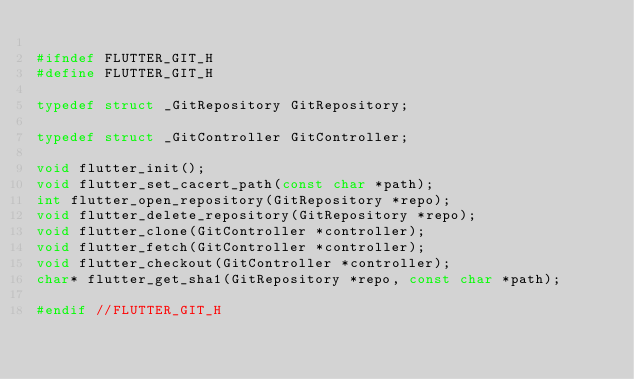<code> <loc_0><loc_0><loc_500><loc_500><_C_>
#ifndef FLUTTER_GIT_H
#define FLUTTER_GIT_H

typedef struct _GitRepository GitRepository;

typedef struct _GitController GitController;

void flutter_init();
void flutter_set_cacert_path(const char *path);
int flutter_open_repository(GitRepository *repo);
void flutter_delete_repository(GitRepository *repo);
void flutter_clone(GitController *controller);
void flutter_fetch(GitController *controller);
void flutter_checkout(GitController *controller);
char* flutter_get_sha1(GitRepository *repo, const char *path);

#endif //FLUTTER_GIT_H
</code> 